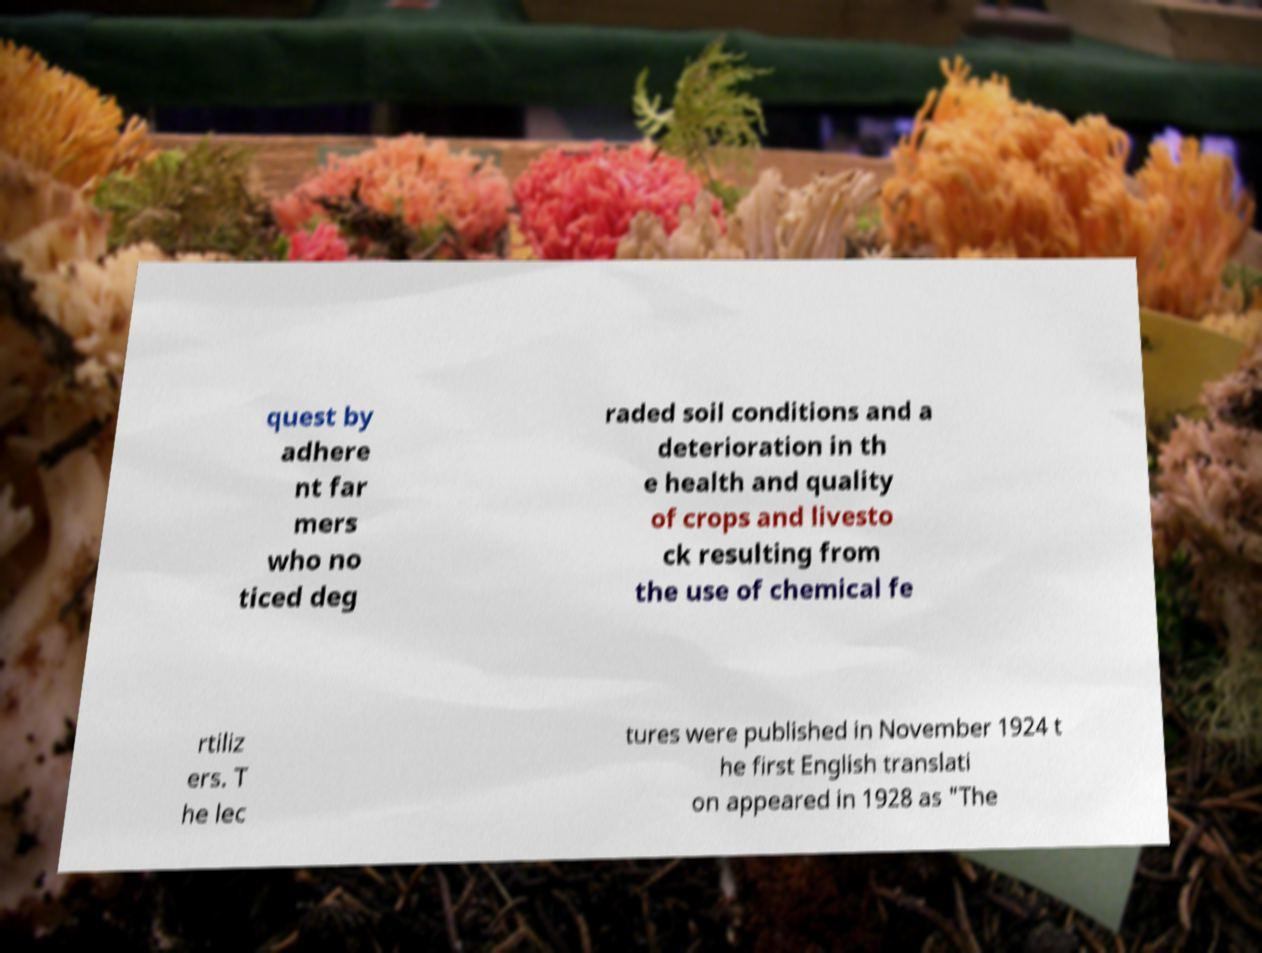Please identify and transcribe the text found in this image. quest by adhere nt far mers who no ticed deg raded soil conditions and a deterioration in th e health and quality of crops and livesto ck resulting from the use of chemical fe rtiliz ers. T he lec tures were published in November 1924 t he first English translati on appeared in 1928 as "The 